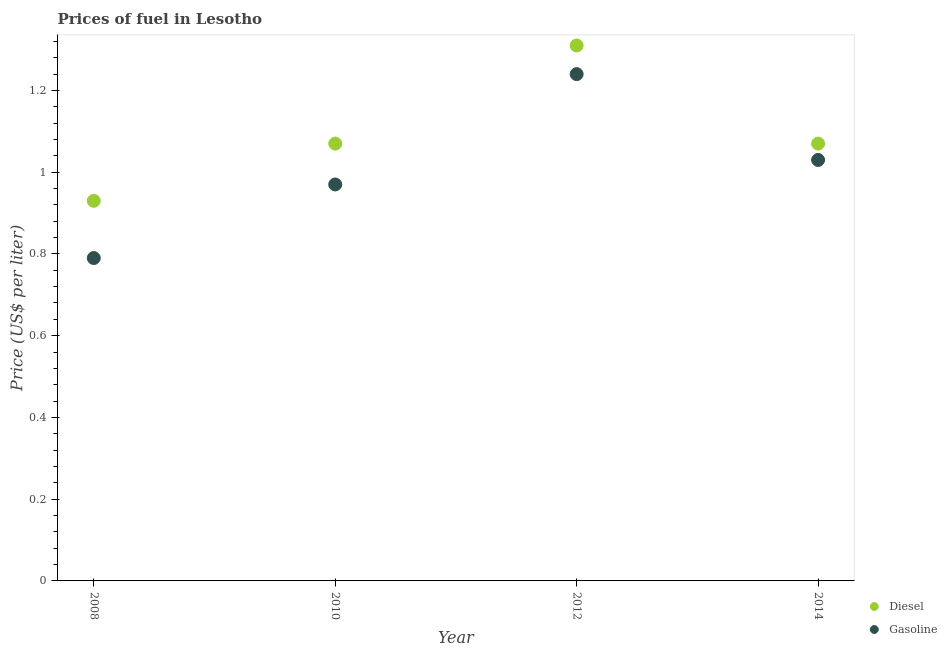Is the number of dotlines equal to the number of legend labels?
Offer a terse response. Yes. What is the gasoline price in 2012?
Your response must be concise. 1.24. Across all years, what is the maximum gasoline price?
Make the answer very short. 1.24. Across all years, what is the minimum gasoline price?
Offer a very short reply. 0.79. In which year was the diesel price minimum?
Give a very brief answer. 2008. What is the total gasoline price in the graph?
Offer a terse response. 4.03. What is the difference between the diesel price in 2010 and that in 2012?
Offer a terse response. -0.24. What is the difference between the gasoline price in 2014 and the diesel price in 2008?
Offer a very short reply. 0.1. What is the average gasoline price per year?
Give a very brief answer. 1.01. In the year 2012, what is the difference between the diesel price and gasoline price?
Keep it short and to the point. 0.07. In how many years, is the diesel price greater than 0.12 US$ per litre?
Make the answer very short. 4. What is the ratio of the gasoline price in 2008 to that in 2012?
Provide a succinct answer. 0.64. Is the diesel price in 2008 less than that in 2014?
Give a very brief answer. Yes. What is the difference between the highest and the second highest diesel price?
Give a very brief answer. 0.24. What is the difference between the highest and the lowest gasoline price?
Your answer should be very brief. 0.45. Is the sum of the diesel price in 2008 and 2012 greater than the maximum gasoline price across all years?
Provide a succinct answer. Yes. Is the gasoline price strictly greater than the diesel price over the years?
Make the answer very short. No. Is the diesel price strictly less than the gasoline price over the years?
Provide a succinct answer. No. How many dotlines are there?
Your answer should be compact. 2. What is the difference between two consecutive major ticks on the Y-axis?
Give a very brief answer. 0.2. Does the graph contain any zero values?
Ensure brevity in your answer.  No. What is the title of the graph?
Make the answer very short. Prices of fuel in Lesotho. Does "Depositors" appear as one of the legend labels in the graph?
Your response must be concise. No. What is the label or title of the X-axis?
Offer a terse response. Year. What is the label or title of the Y-axis?
Offer a terse response. Price (US$ per liter). What is the Price (US$ per liter) in Diesel in 2008?
Ensure brevity in your answer.  0.93. What is the Price (US$ per liter) of Gasoline in 2008?
Keep it short and to the point. 0.79. What is the Price (US$ per liter) of Diesel in 2010?
Your answer should be very brief. 1.07. What is the Price (US$ per liter) in Gasoline in 2010?
Your response must be concise. 0.97. What is the Price (US$ per liter) of Diesel in 2012?
Your answer should be very brief. 1.31. What is the Price (US$ per liter) in Gasoline in 2012?
Offer a very short reply. 1.24. What is the Price (US$ per liter) of Diesel in 2014?
Provide a succinct answer. 1.07. What is the Price (US$ per liter) of Gasoline in 2014?
Give a very brief answer. 1.03. Across all years, what is the maximum Price (US$ per liter) of Diesel?
Ensure brevity in your answer.  1.31. Across all years, what is the maximum Price (US$ per liter) in Gasoline?
Offer a very short reply. 1.24. Across all years, what is the minimum Price (US$ per liter) of Gasoline?
Your answer should be very brief. 0.79. What is the total Price (US$ per liter) in Diesel in the graph?
Ensure brevity in your answer.  4.38. What is the total Price (US$ per liter) of Gasoline in the graph?
Keep it short and to the point. 4.03. What is the difference between the Price (US$ per liter) in Diesel in 2008 and that in 2010?
Offer a very short reply. -0.14. What is the difference between the Price (US$ per liter) in Gasoline in 2008 and that in 2010?
Your response must be concise. -0.18. What is the difference between the Price (US$ per liter) of Diesel in 2008 and that in 2012?
Provide a succinct answer. -0.38. What is the difference between the Price (US$ per liter) of Gasoline in 2008 and that in 2012?
Keep it short and to the point. -0.45. What is the difference between the Price (US$ per liter) in Diesel in 2008 and that in 2014?
Your answer should be compact. -0.14. What is the difference between the Price (US$ per liter) in Gasoline in 2008 and that in 2014?
Keep it short and to the point. -0.24. What is the difference between the Price (US$ per liter) in Diesel in 2010 and that in 2012?
Give a very brief answer. -0.24. What is the difference between the Price (US$ per liter) of Gasoline in 2010 and that in 2012?
Ensure brevity in your answer.  -0.27. What is the difference between the Price (US$ per liter) of Diesel in 2010 and that in 2014?
Provide a short and direct response. 0. What is the difference between the Price (US$ per liter) in Gasoline in 2010 and that in 2014?
Offer a very short reply. -0.06. What is the difference between the Price (US$ per liter) of Diesel in 2012 and that in 2014?
Provide a succinct answer. 0.24. What is the difference between the Price (US$ per liter) of Gasoline in 2012 and that in 2014?
Keep it short and to the point. 0.21. What is the difference between the Price (US$ per liter) in Diesel in 2008 and the Price (US$ per liter) in Gasoline in 2010?
Give a very brief answer. -0.04. What is the difference between the Price (US$ per liter) of Diesel in 2008 and the Price (US$ per liter) of Gasoline in 2012?
Give a very brief answer. -0.31. What is the difference between the Price (US$ per liter) of Diesel in 2008 and the Price (US$ per liter) of Gasoline in 2014?
Provide a succinct answer. -0.1. What is the difference between the Price (US$ per liter) of Diesel in 2010 and the Price (US$ per liter) of Gasoline in 2012?
Give a very brief answer. -0.17. What is the difference between the Price (US$ per liter) in Diesel in 2012 and the Price (US$ per liter) in Gasoline in 2014?
Give a very brief answer. 0.28. What is the average Price (US$ per liter) of Diesel per year?
Your response must be concise. 1.09. What is the average Price (US$ per liter) in Gasoline per year?
Offer a very short reply. 1.01. In the year 2008, what is the difference between the Price (US$ per liter) of Diesel and Price (US$ per liter) of Gasoline?
Keep it short and to the point. 0.14. In the year 2010, what is the difference between the Price (US$ per liter) of Diesel and Price (US$ per liter) of Gasoline?
Offer a terse response. 0.1. In the year 2012, what is the difference between the Price (US$ per liter) in Diesel and Price (US$ per liter) in Gasoline?
Your answer should be very brief. 0.07. In the year 2014, what is the difference between the Price (US$ per liter) in Diesel and Price (US$ per liter) in Gasoline?
Provide a succinct answer. 0.04. What is the ratio of the Price (US$ per liter) in Diesel in 2008 to that in 2010?
Offer a terse response. 0.87. What is the ratio of the Price (US$ per liter) of Gasoline in 2008 to that in 2010?
Offer a very short reply. 0.81. What is the ratio of the Price (US$ per liter) of Diesel in 2008 to that in 2012?
Keep it short and to the point. 0.71. What is the ratio of the Price (US$ per liter) of Gasoline in 2008 to that in 2012?
Make the answer very short. 0.64. What is the ratio of the Price (US$ per liter) in Diesel in 2008 to that in 2014?
Keep it short and to the point. 0.87. What is the ratio of the Price (US$ per liter) in Gasoline in 2008 to that in 2014?
Provide a short and direct response. 0.77. What is the ratio of the Price (US$ per liter) of Diesel in 2010 to that in 2012?
Offer a terse response. 0.82. What is the ratio of the Price (US$ per liter) of Gasoline in 2010 to that in 2012?
Offer a terse response. 0.78. What is the ratio of the Price (US$ per liter) of Diesel in 2010 to that in 2014?
Your answer should be very brief. 1. What is the ratio of the Price (US$ per liter) in Gasoline in 2010 to that in 2014?
Make the answer very short. 0.94. What is the ratio of the Price (US$ per liter) in Diesel in 2012 to that in 2014?
Offer a very short reply. 1.22. What is the ratio of the Price (US$ per liter) in Gasoline in 2012 to that in 2014?
Make the answer very short. 1.2. What is the difference between the highest and the second highest Price (US$ per liter) of Diesel?
Provide a short and direct response. 0.24. What is the difference between the highest and the second highest Price (US$ per liter) in Gasoline?
Offer a very short reply. 0.21. What is the difference between the highest and the lowest Price (US$ per liter) in Diesel?
Your answer should be very brief. 0.38. What is the difference between the highest and the lowest Price (US$ per liter) in Gasoline?
Give a very brief answer. 0.45. 